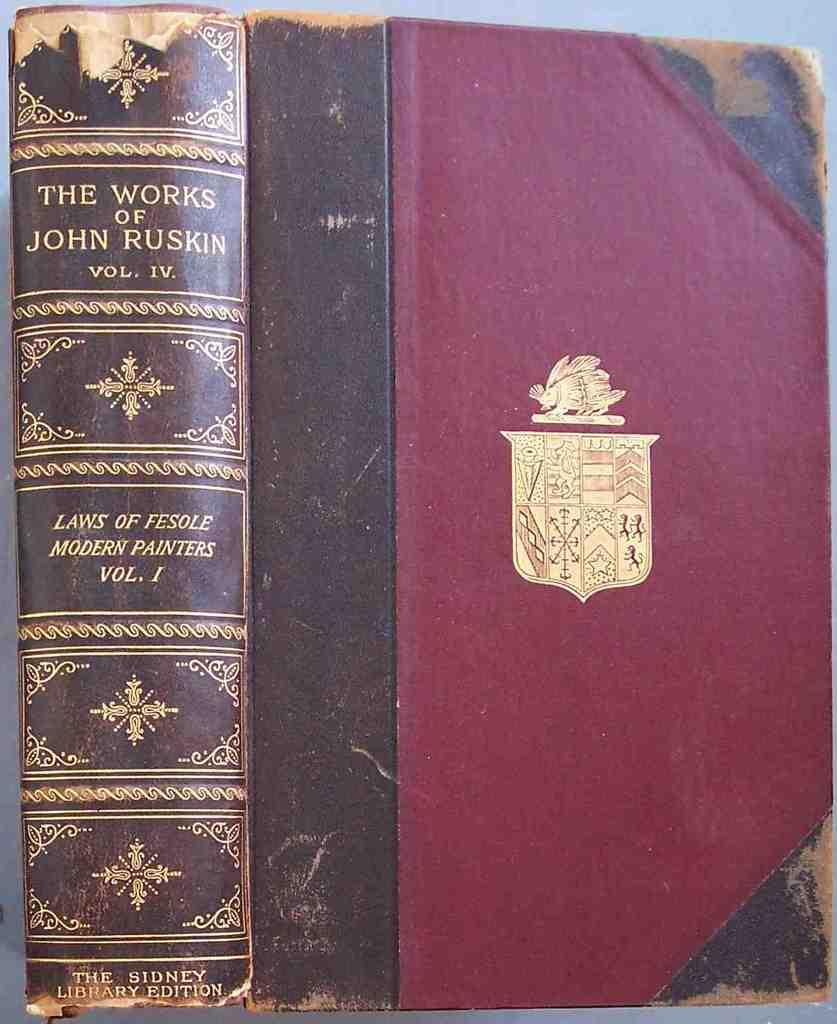<image>
Render a clear and concise summary of the photo. An old leather bound book called "The Works of John Ruskin Volume IV". 